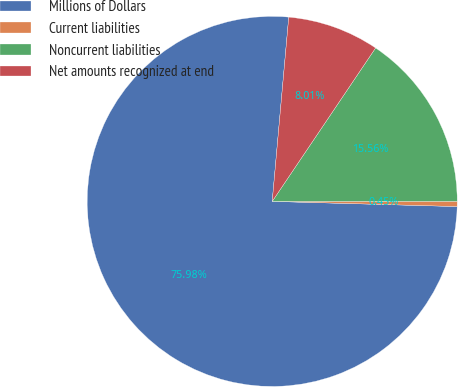Convert chart to OTSL. <chart><loc_0><loc_0><loc_500><loc_500><pie_chart><fcel>Millions of Dollars<fcel>Current liabilities<fcel>Noncurrent liabilities<fcel>Net amounts recognized at end<nl><fcel>75.98%<fcel>0.45%<fcel>15.56%<fcel>8.01%<nl></chart> 